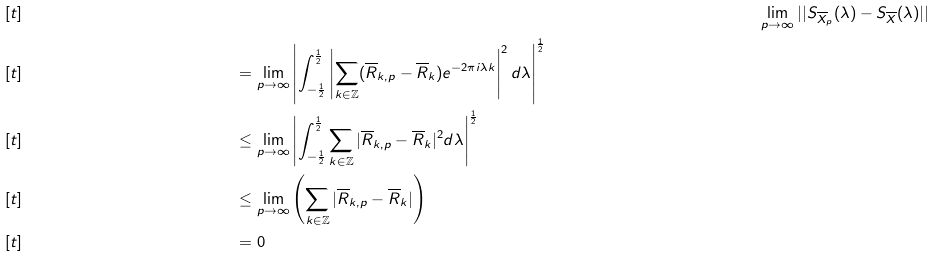<formula> <loc_0><loc_0><loc_500><loc_500>& \, [ t ] & & & & \lim _ { p \to \infty } | | S _ { \overline { X } _ { p } } ( \lambda ) - S _ { \overline { X } } ( \lambda ) | | \\ & \, [ t ] & & = \lim _ { p \to \infty } \left | \int _ { - \frac { 1 } { 2 } } ^ { \frac { 1 } { 2 } } \left | \sum _ { k \in \mathbb { Z } } ( \overline { R } _ { k , p } - \overline { R } _ { k } ) e ^ { - 2 \pi i \lambda k } \right | ^ { 2 } d \lambda \right | ^ { \frac { 1 } { 2 } } \\ & \, [ t ] & & \leq \lim _ { p \to \infty } \left | \int _ { - \frac { 1 } { 2 } } ^ { \frac { 1 } { 2 } } \sum _ { k \in \mathbb { Z } } | \overline { R } _ { k , p } - \overline { R } _ { k } | ^ { 2 } d \lambda \right | ^ { \frac { 1 } { 2 } } \\ & \, [ t ] & & \leq \lim _ { p \to \infty } \left ( \sum _ { k \in \mathbb { Z } } | \overline { R } _ { k , p } - \overline { R } _ { k } | \right ) \\ & \, [ t ] & & = 0 \\</formula> 